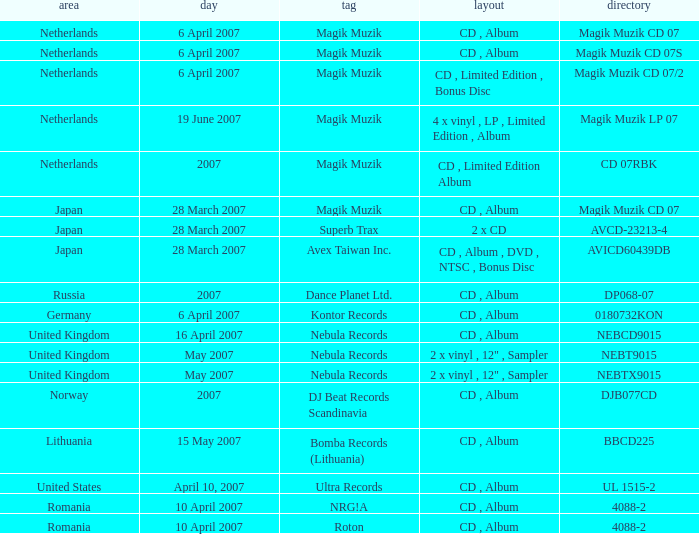Which label released the catalog Magik Muzik CD 07 on 28 March 2007? Magik Muzik. 